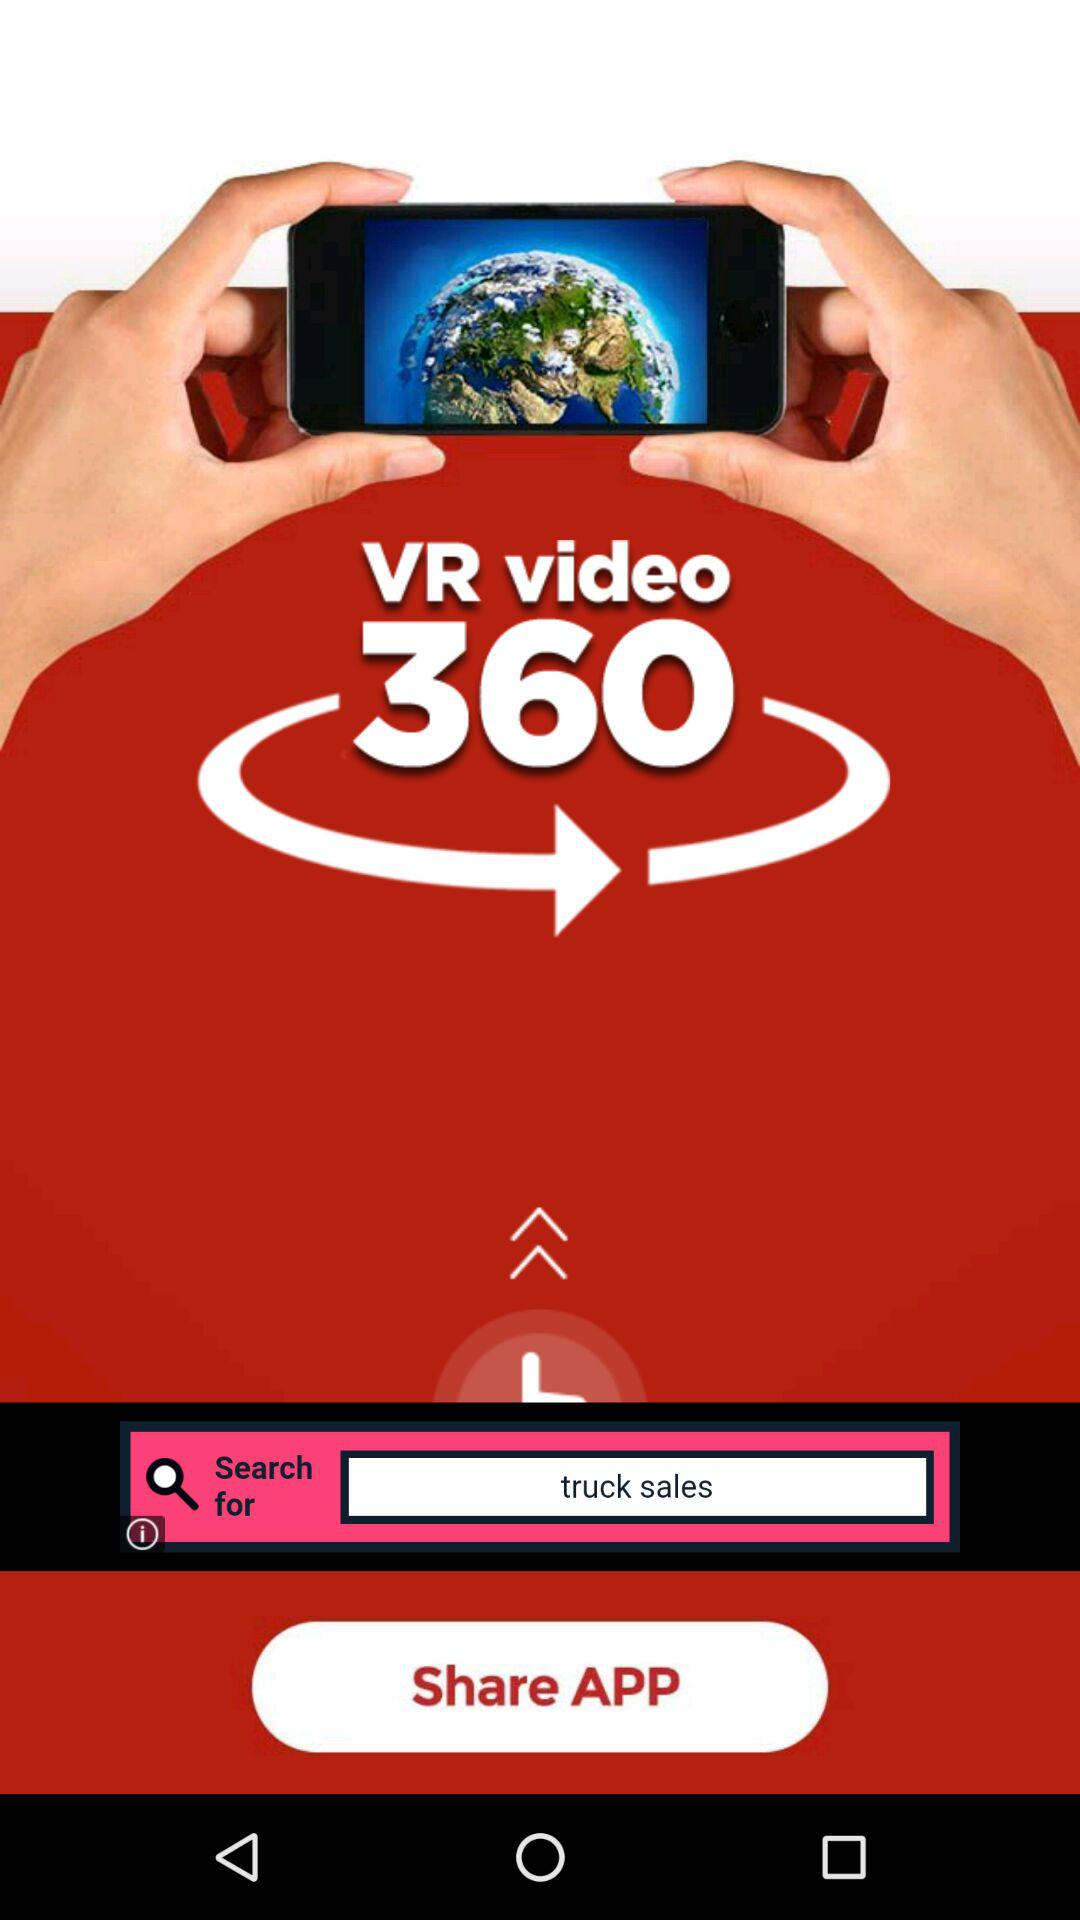What is the app name? The app name is "VR video 360". 